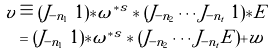Convert formula to latex. <formula><loc_0><loc_0><loc_500><loc_500>v & \equiv ( J _ { - n _ { 1 } } \ 1 ) * \omega ^ { * s } * ( J _ { - n _ { 2 } } \cdots J _ { - n _ { t } } \ 1 ) * E \\ & = ( J _ { - n _ { 1 } } \ 1 ) * \omega ^ { * s } * ( J _ { - n _ { 2 } } \cdots J _ { - n _ { t } } E ) + w</formula> 